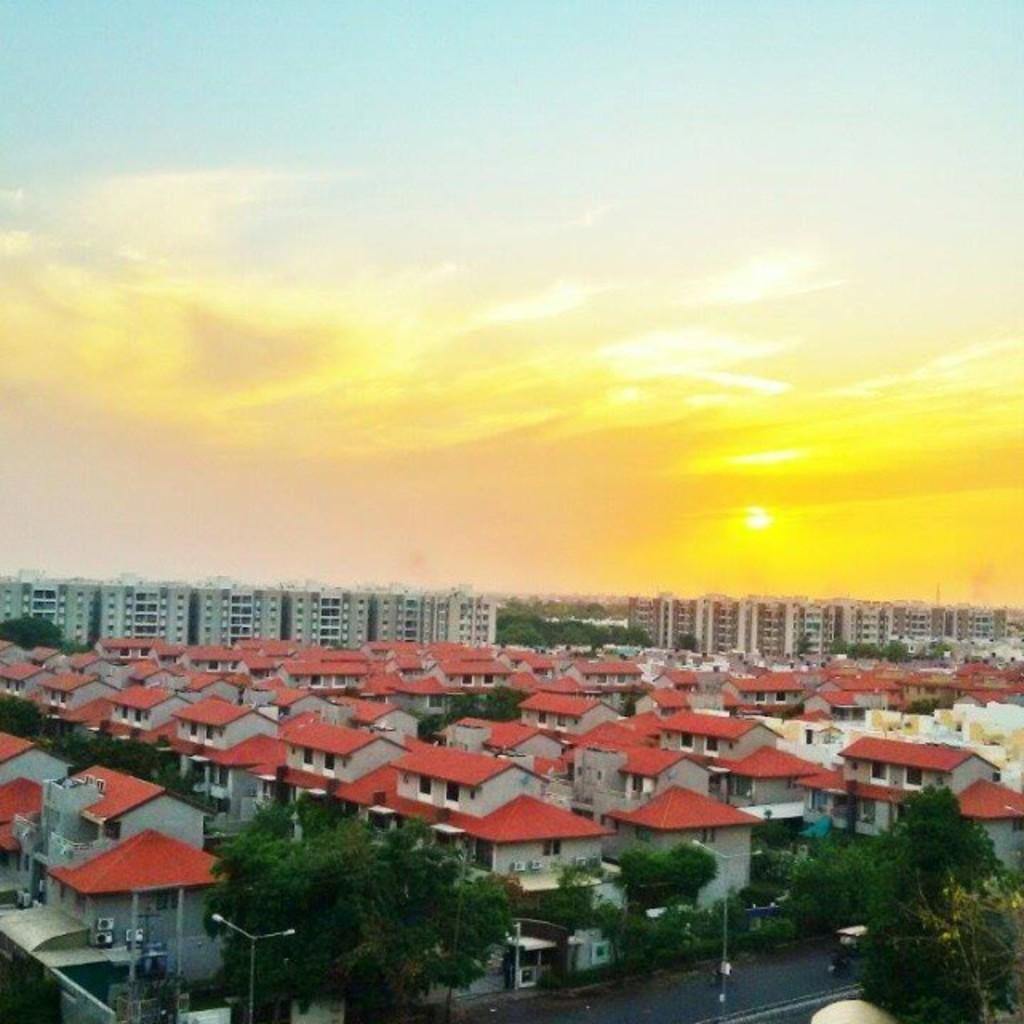What type of structures can be seen in the image? There are houses, trees, plants, poles, a road, buildings, and the sky is visible in the background of the image. Can you describe the vegetation in the image? There are trees and plants in the image. What type of infrastructure is present in the image? There are poles and a road in the image. What can be seen in the sky in the image? There are clouds in the sky. Where is the cow located in the image? There is no cow present in the image. What mark can be seen on the road in the image? There is no mark mentioned on the road in the image. 